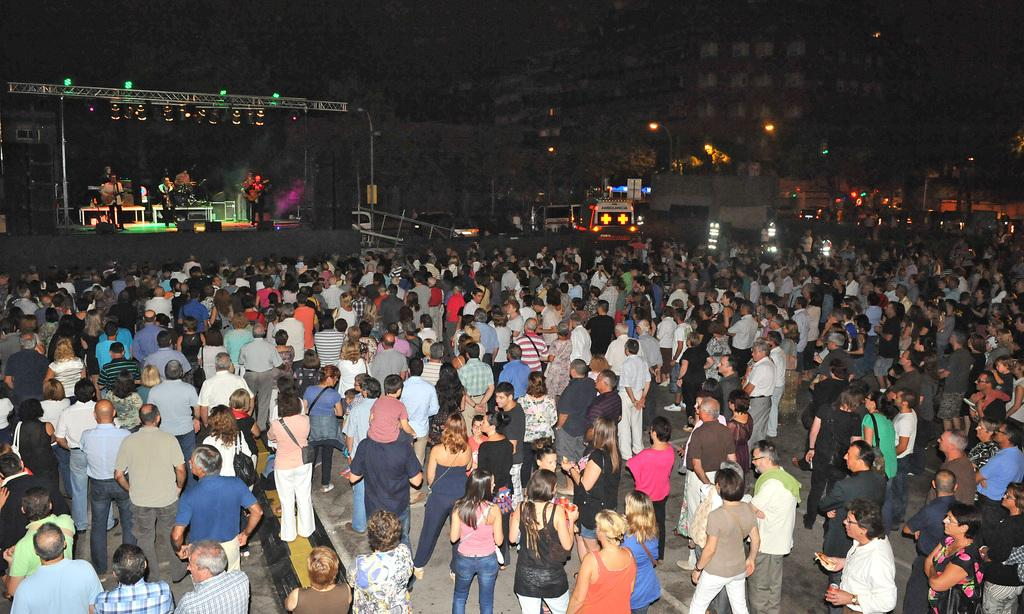What is happening in the image? There are people standing in the image, and some of them are performing on a stage. What can be seen in the background of the image? There are buildings visible in the image. What else is present in the image besides the people and stage? There are lights visible in the image. What type of force is being used by the performers on the stage? There is no indication of any force being used by the performers in the image. Can you tell me if there is a spy present in the image? There is no mention of a spy in the image, and no such figure can be seen. 